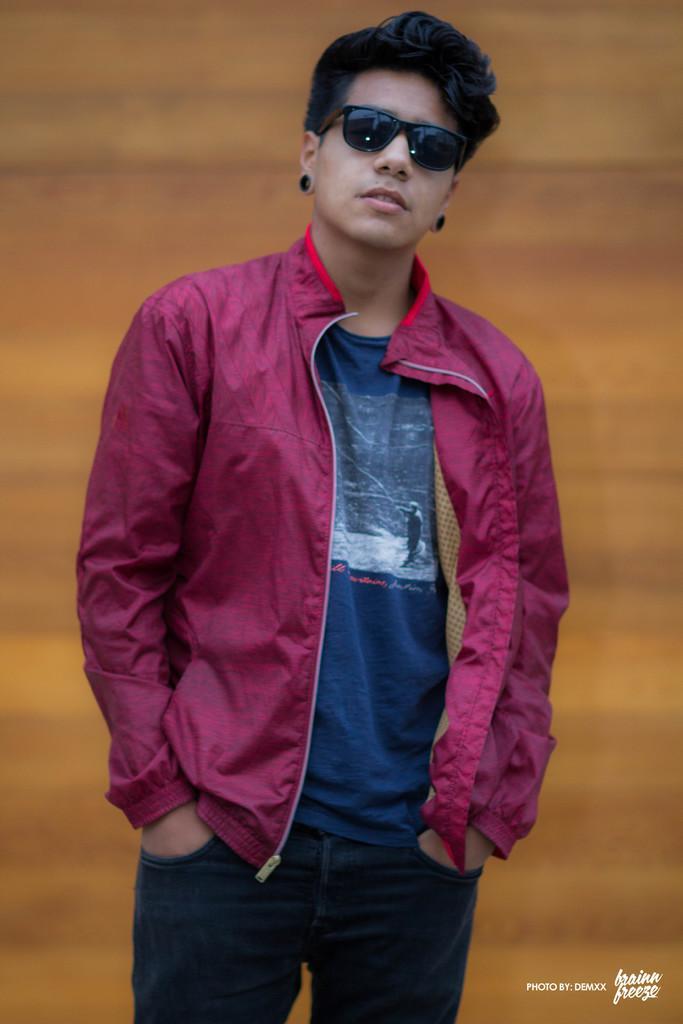Can you describe this image briefly? In the center of the image we can see a man wearing glasses and standing and the background is blurred. We can also see the text at the bottom. 